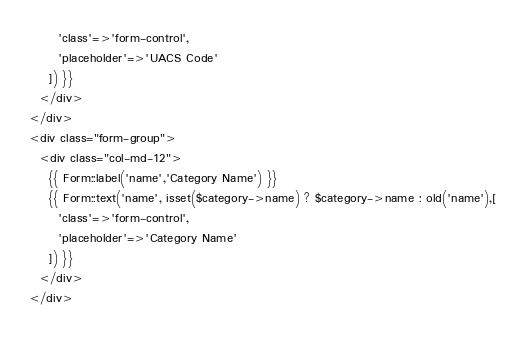<code> <loc_0><loc_0><loc_500><loc_500><_PHP_>      'class'=>'form-control',
      'placeholder'=>'UACS Code'
    ]) }}
  </div>
</div>
<div class="form-group">
  <div class="col-md-12">
    {{ Form::label('name','Category Name') }}
    {{ Form::text('name', isset($category->name) ? $category->name : old('name'),[
      'class'=>'form-control',
      'placeholder'=>'Category Name'
    ]) }}
  </div>
</div></code> 